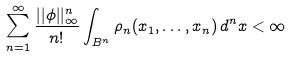<formula> <loc_0><loc_0><loc_500><loc_500>\sum _ { n = 1 } ^ { \infty } \frac { | | \phi | | _ { \infty } ^ { n } } { n ! } \int _ { B ^ { n } } \rho _ { n } ( x _ { 1 } , \dots , x _ { n } ) \, d ^ { n } x < \infty</formula> 